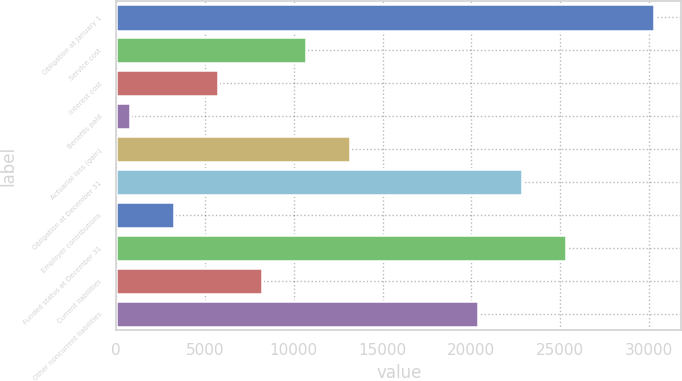<chart> <loc_0><loc_0><loc_500><loc_500><bar_chart><fcel>Obligation at January 1<fcel>Service cost<fcel>Interest cost<fcel>Benefits paid<fcel>Actuarial loss (gain)<fcel>Obligation at December 31<fcel>Employer contributions<fcel>Funded status at December 31<fcel>Current liabilities<fcel>Other noncurrent liabilities<nl><fcel>30322.4<fcel>10715.4<fcel>5758.2<fcel>801<fcel>13194<fcel>22886.6<fcel>3279.6<fcel>25365.2<fcel>8236.8<fcel>20408<nl></chart> 